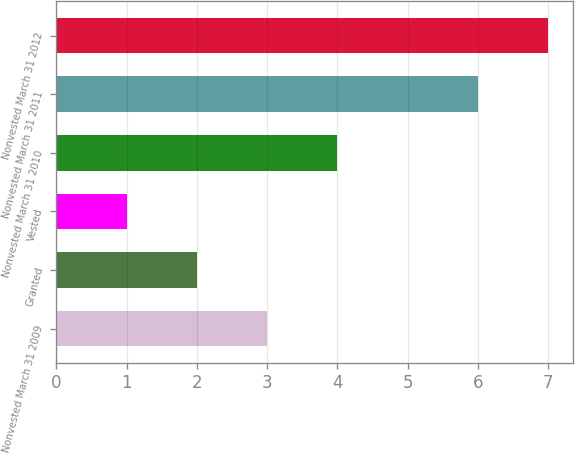Convert chart. <chart><loc_0><loc_0><loc_500><loc_500><bar_chart><fcel>Nonvested March 31 2009<fcel>Granted<fcel>Vested<fcel>Nonvested March 31 2010<fcel>Nonvested March 31 2011<fcel>Nonvested March 31 2012<nl><fcel>3<fcel>2<fcel>1<fcel>4<fcel>6<fcel>7<nl></chart> 